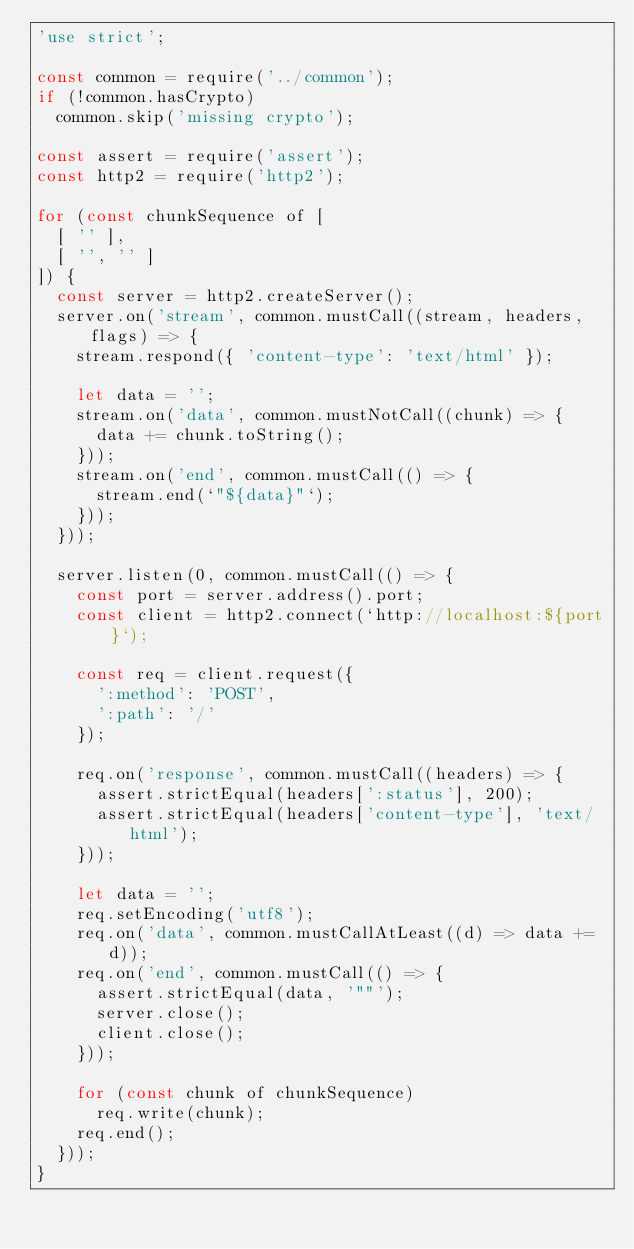<code> <loc_0><loc_0><loc_500><loc_500><_JavaScript_>'use strict';

const common = require('../common');
if (!common.hasCrypto)
  common.skip('missing crypto');

const assert = require('assert');
const http2 = require('http2');

for (const chunkSequence of [
  [ '' ],
  [ '', '' ]
]) {
  const server = http2.createServer();
  server.on('stream', common.mustCall((stream, headers, flags) => {
    stream.respond({ 'content-type': 'text/html' });

    let data = '';
    stream.on('data', common.mustNotCall((chunk) => {
      data += chunk.toString();
    }));
    stream.on('end', common.mustCall(() => {
      stream.end(`"${data}"`);
    }));
  }));

  server.listen(0, common.mustCall(() => {
    const port = server.address().port;
    const client = http2.connect(`http://localhost:${port}`);

    const req = client.request({
      ':method': 'POST',
      ':path': '/'
    });

    req.on('response', common.mustCall((headers) => {
      assert.strictEqual(headers[':status'], 200);
      assert.strictEqual(headers['content-type'], 'text/html');
    }));

    let data = '';
    req.setEncoding('utf8');
    req.on('data', common.mustCallAtLeast((d) => data += d));
    req.on('end', common.mustCall(() => {
      assert.strictEqual(data, '""');
      server.close();
      client.close();
    }));

    for (const chunk of chunkSequence)
      req.write(chunk);
    req.end();
  }));
}
</code> 